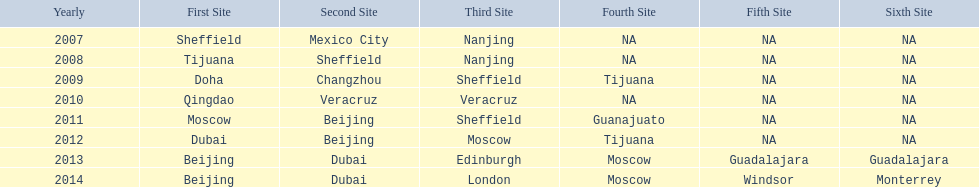Name a year whose second venue was the same as 2011. 2012. 